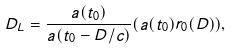<formula> <loc_0><loc_0><loc_500><loc_500>D _ { L } = \frac { a ( t _ { 0 } ) } { a ( t _ { 0 } - D / c ) } ( a ( t _ { 0 } ) r _ { 0 } ( D ) ) ,</formula> 